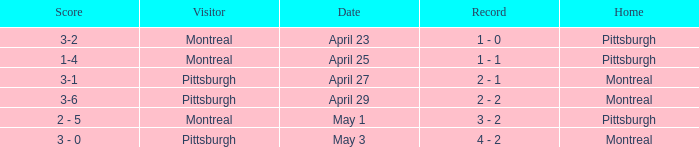What was the score on April 25? 1-4. 